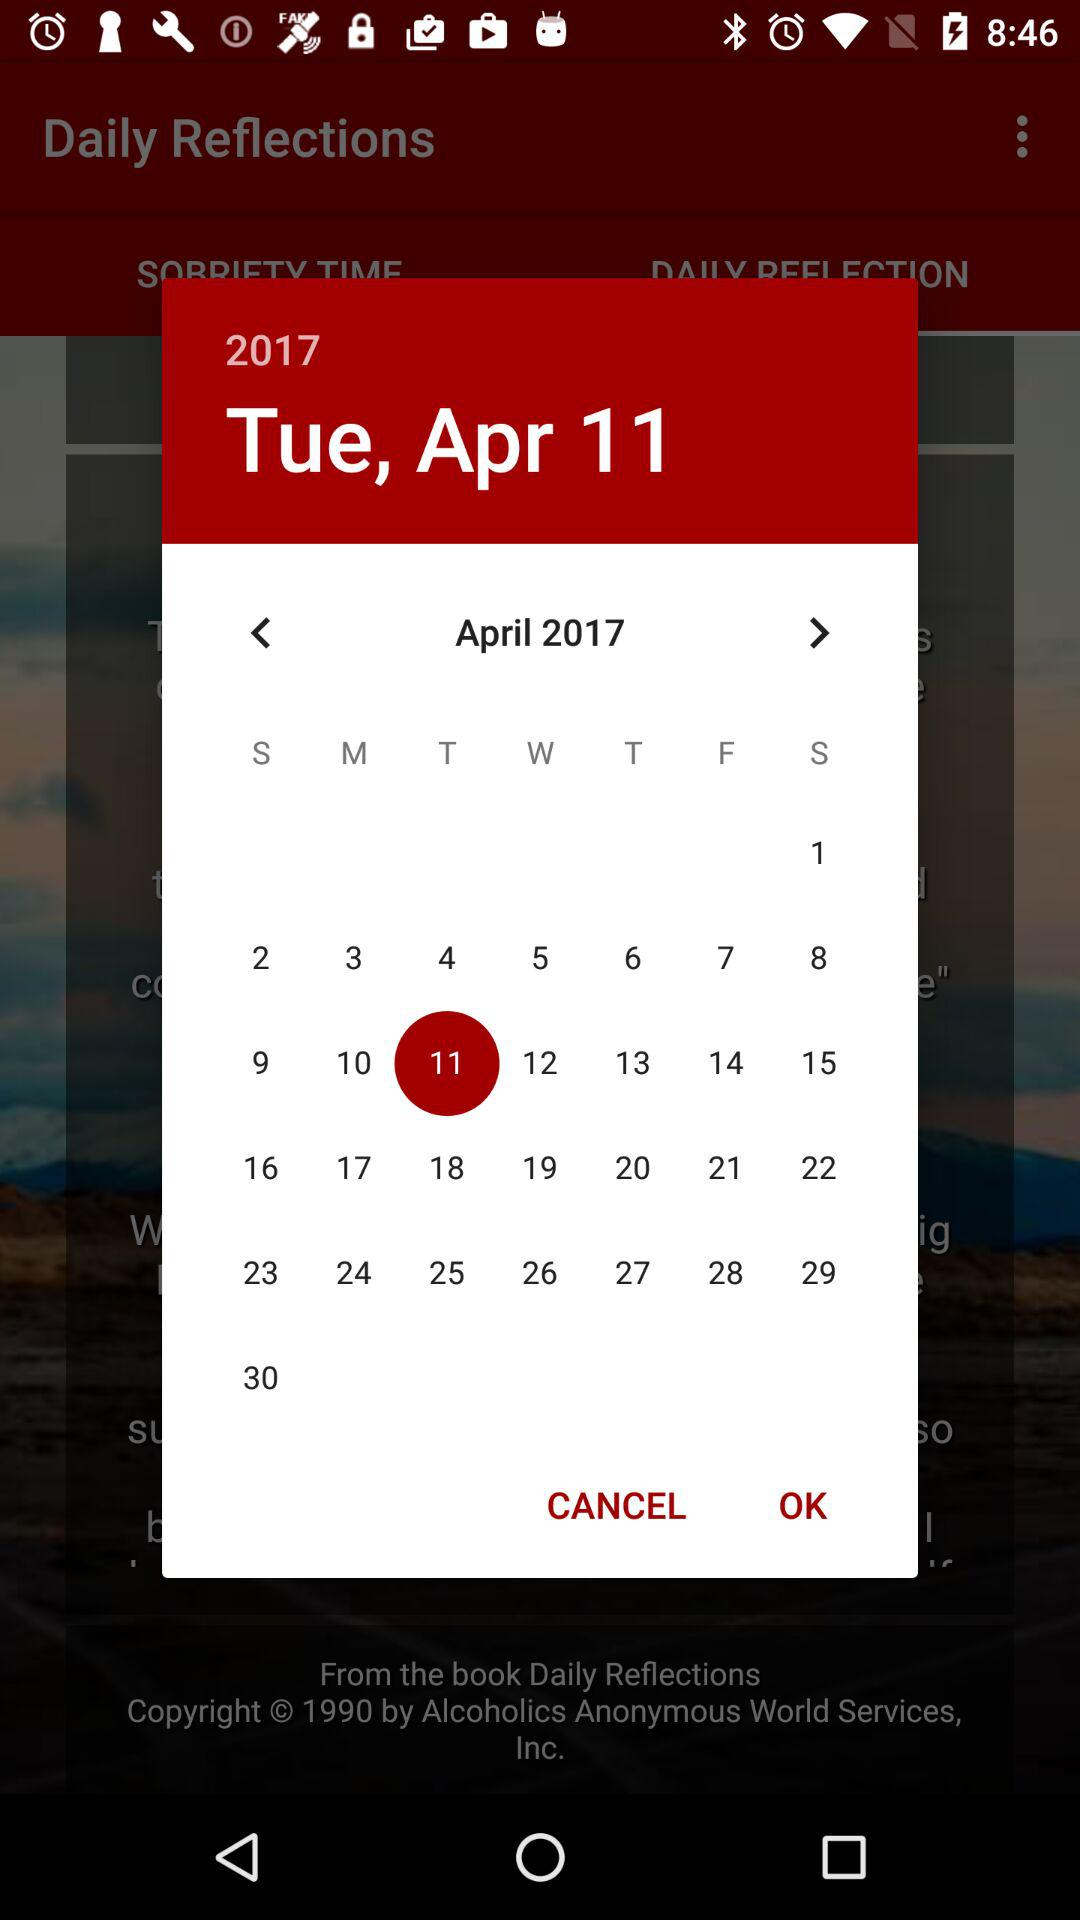What date is chosen? The chosen date is Tuesday, April 11, 2017. 